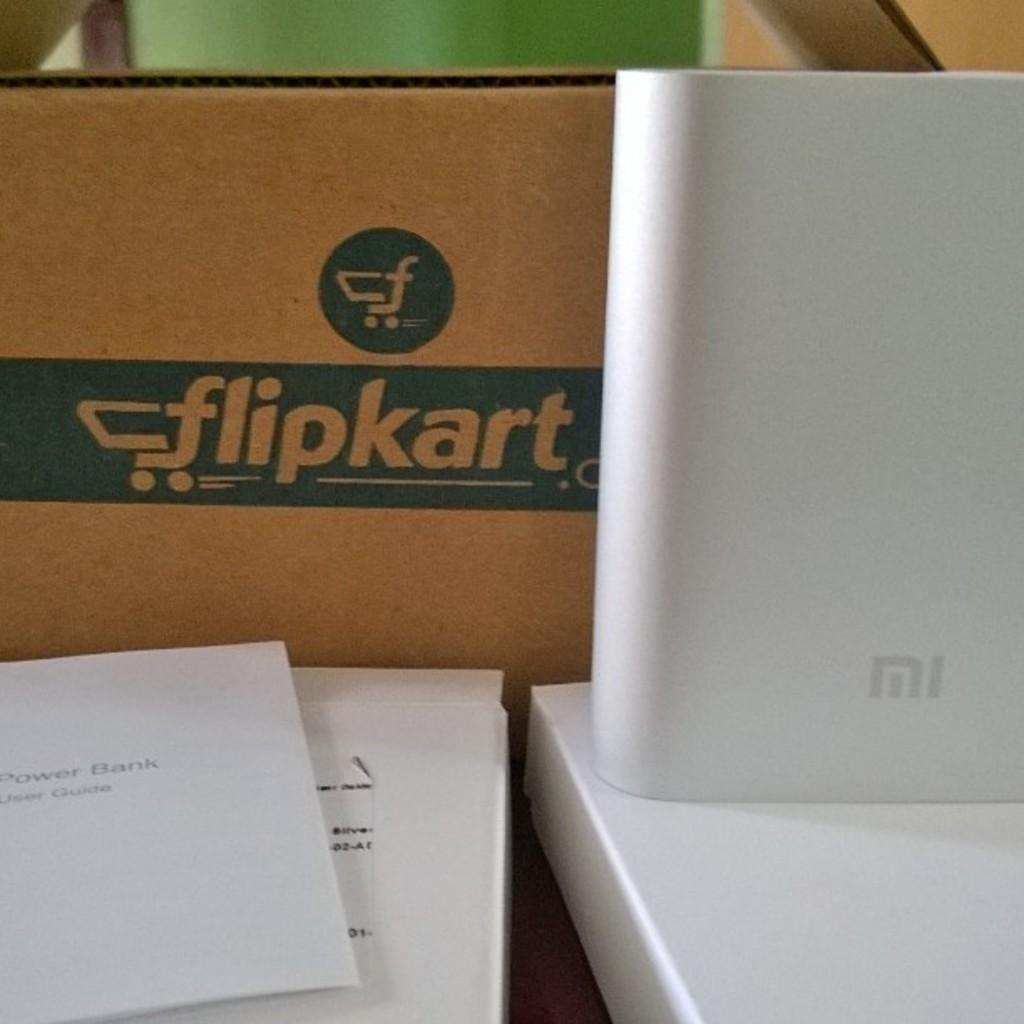What type of objects are in the image? There are boxes in the image. Can you identify any specific brand of box in the image? Yes, there is a Flipkart cardboard box in the image. What item is visible inside one of the boxes? There is an MI power bank in the image. What type of thread is used to sew the territory on the box? There is no mention of sewing or territory on the box in the image. What type of cream is visible in the image? There is no cream visible in the image. 